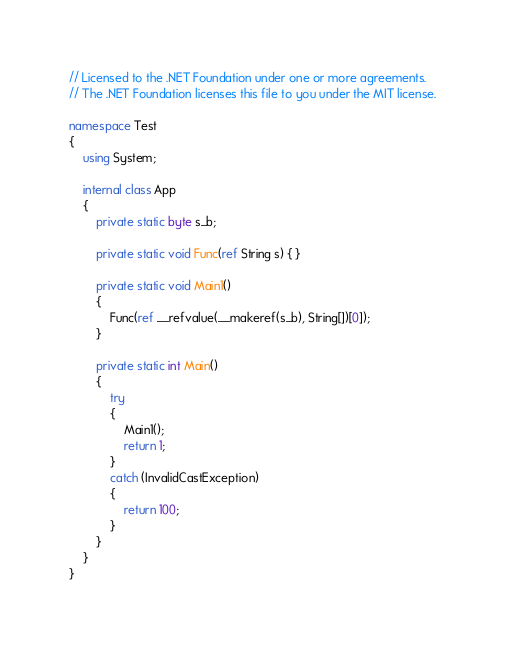Convert code to text. <code><loc_0><loc_0><loc_500><loc_500><_C#_>// Licensed to the .NET Foundation under one or more agreements.
// The .NET Foundation licenses this file to you under the MIT license.

namespace Test
{
    using System;

    internal class App
    {
        private static byte s_b;

        private static void Func(ref String s) { }

        private static void Main1()
        {
            Func(ref __refvalue(__makeref(s_b), String[])[0]);
        }

        private static int Main()
        {
            try
            {
                Main1();
                return 1;
            }
            catch (InvalidCastException)
            {
                return 100;
            }
        }
    }
}
</code> 